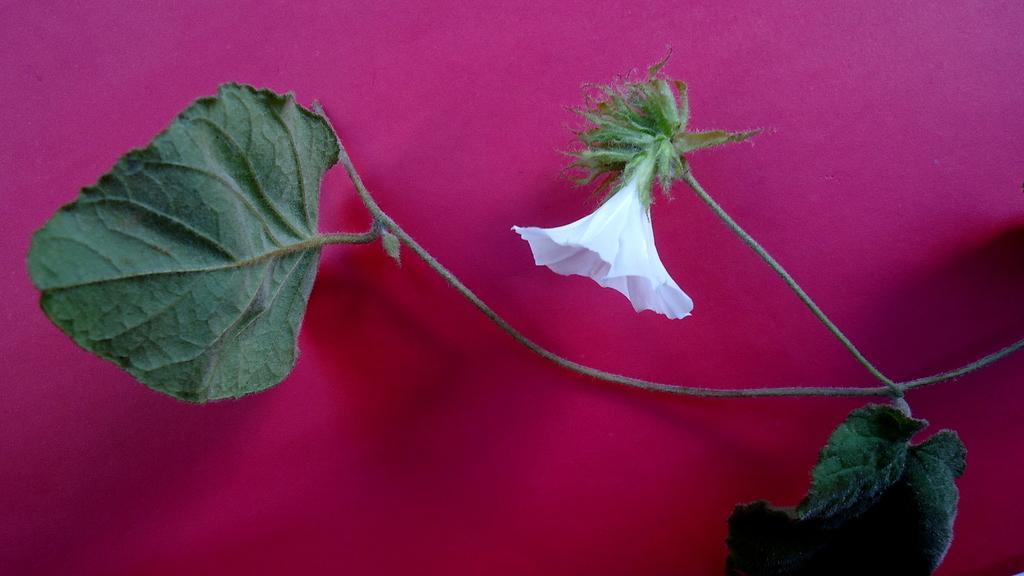How would you summarize this image in a sentence or two? On the right side, there is a plant having green color leaves and a white color flower. And the background is pink in color. 